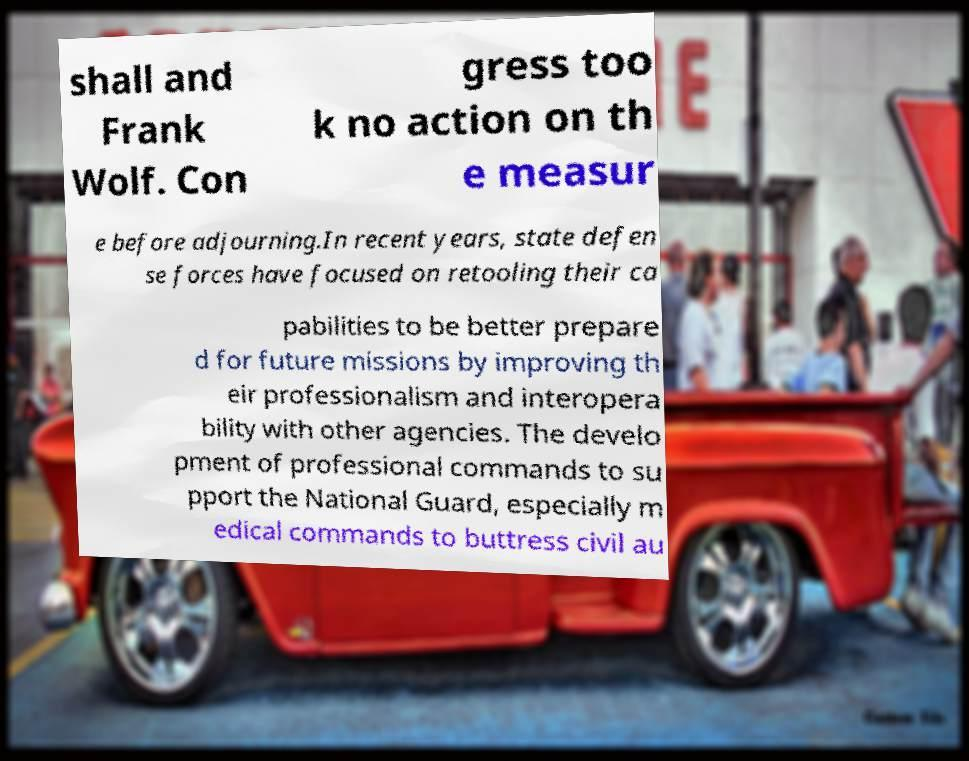Please identify and transcribe the text found in this image. shall and Frank Wolf. Con gress too k no action on th e measur e before adjourning.In recent years, state defen se forces have focused on retooling their ca pabilities to be better prepare d for future missions by improving th eir professionalism and interopera bility with other agencies. The develo pment of professional commands to su pport the National Guard, especially m edical commands to buttress civil au 